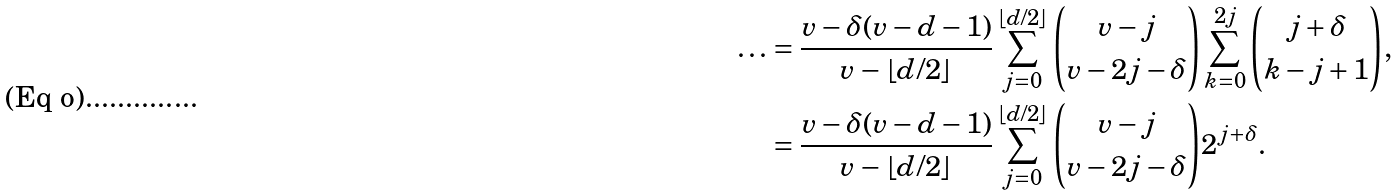Convert formula to latex. <formula><loc_0><loc_0><loc_500><loc_500>\dots & = \frac { v - \delta ( v - d - 1 ) } { v - \lfloor d / 2 \rfloor } \sum _ { j = 0 } ^ { \lfloor d / 2 \rfloor } \binom { v - j } { v - 2 j - \delta } \sum _ { k = 0 } ^ { 2 j } \binom { j + \delta } { k - j + 1 } , \\ & = \frac { v - \delta ( v - d - 1 ) } { v - \lfloor d / 2 \rfloor } \sum _ { j = 0 } ^ { \lfloor d / 2 \rfloor } \binom { v - j } { v - 2 j - \delta } 2 ^ { j + \delta } .</formula> 